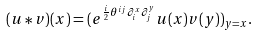<formula> <loc_0><loc_0><loc_500><loc_500>( u * v ) ( x ) = ( e ^ { \frac { i } { 2 } \theta ^ { i j } \partial _ { i } ^ { x } \partial _ { j } ^ { y } } u ( x ) v ( y ) ) _ { y = x } .</formula> 